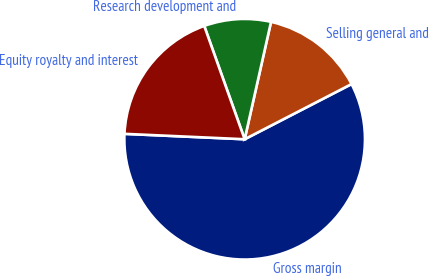Convert chart to OTSL. <chart><loc_0><loc_0><loc_500><loc_500><pie_chart><fcel>Gross margin<fcel>Selling general and<fcel>Research development and<fcel>Equity royalty and interest<nl><fcel>58.3%<fcel>13.9%<fcel>8.97%<fcel>18.83%<nl></chart> 